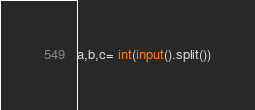<code> <loc_0><loc_0><loc_500><loc_500><_Python_>a,b,c= int(input().split())
</code> 